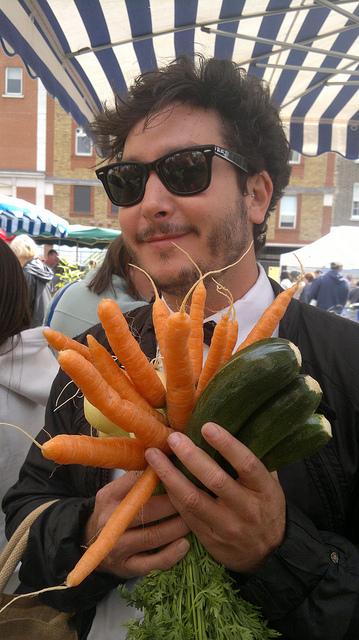Where are the sunglasses?
Short answer required. On man's face. What kind of air conditioning do the people have living in the building?
Concise answer only. Window. What are the green veggies called?
Keep it brief. Cucumbers. 